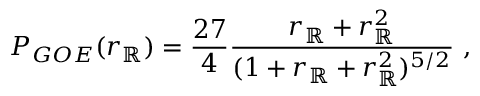<formula> <loc_0><loc_0><loc_500><loc_500>{ P _ { G O E } } ( r _ { \mathbb { R } } ) = \frac { 2 7 } { 4 } \frac { r _ { \mathbb { R } } + r _ { \mathbb { R } } ^ { 2 } } { ( 1 + r _ { \mathbb { R } } + r _ { \mathbb { R } } ^ { 2 } ) ^ { 5 / 2 } } \ ,</formula> 